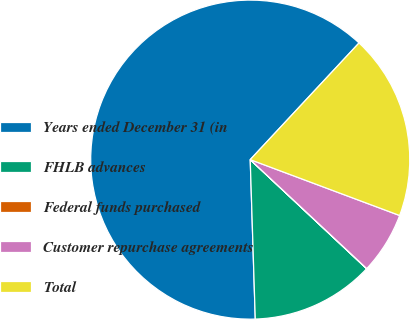Convert chart to OTSL. <chart><loc_0><loc_0><loc_500><loc_500><pie_chart><fcel>Years ended December 31 (in<fcel>FHLB advances<fcel>Federal funds purchased<fcel>Customer repurchase agreements<fcel>Total<nl><fcel>62.45%<fcel>12.51%<fcel>0.02%<fcel>6.27%<fcel>18.75%<nl></chart> 